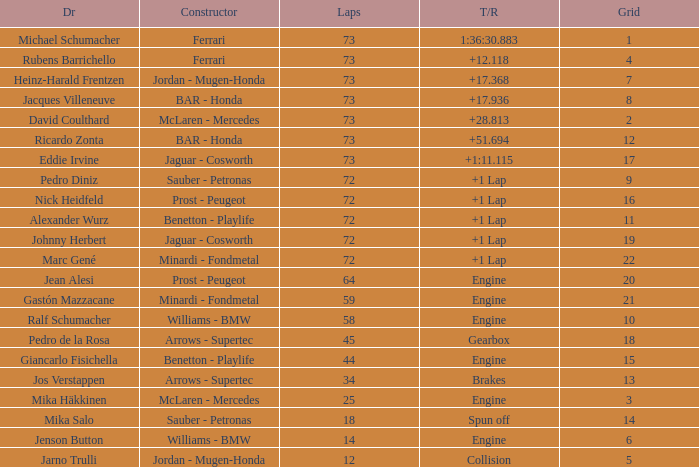How many laps did Giancarlo Fisichella do with a grid larger than 15? 0.0. 